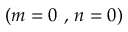<formula> <loc_0><loc_0><loc_500><loc_500>{ ( m = 0 , n = 0 ) }</formula> 